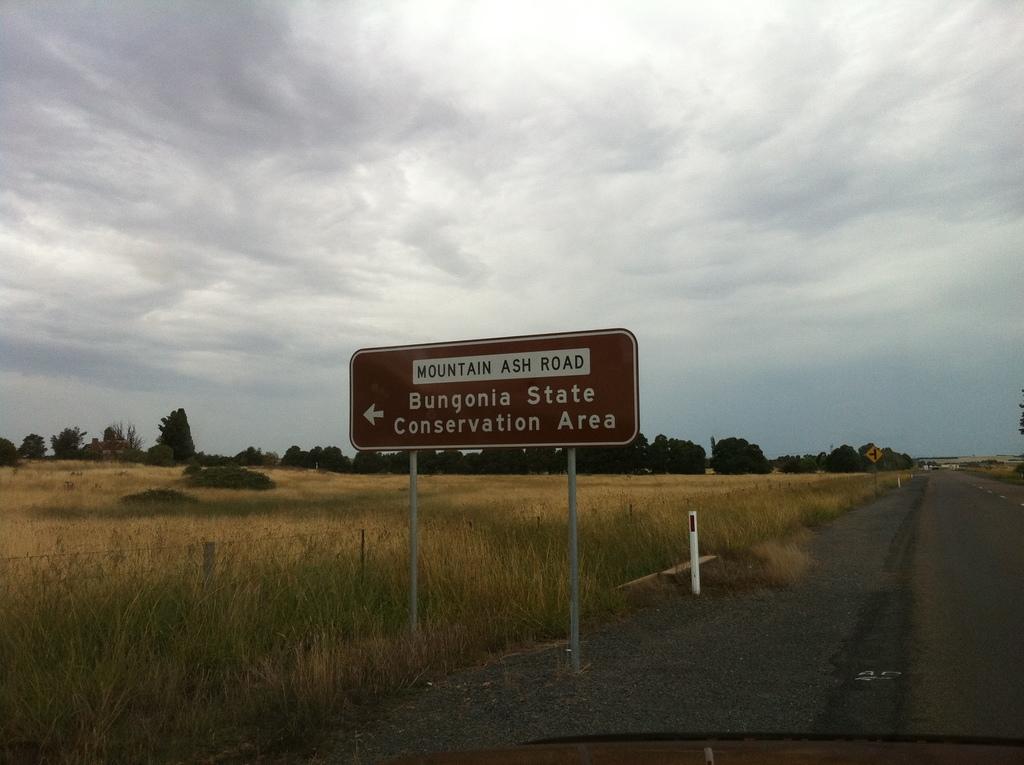What is on mountain ash road?
Make the answer very short. Bungonia state conservation area. What road is bungonia state conservation area on?
Your response must be concise. Mountain ash road. 